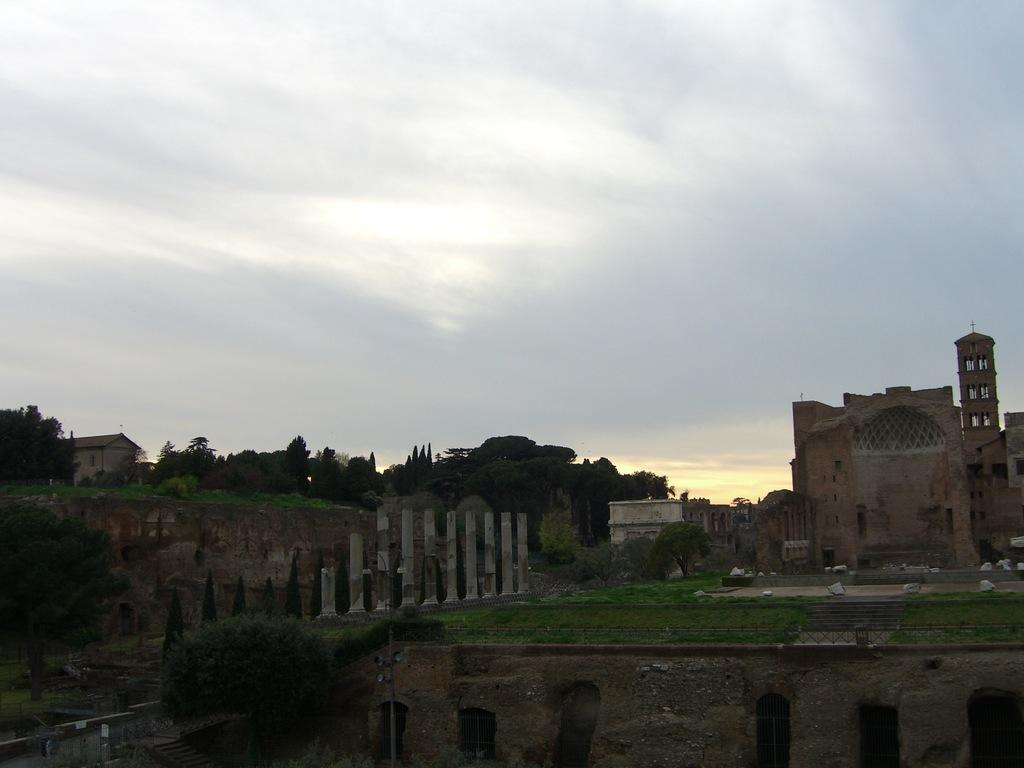What type of natural elements can be seen in the image? There are trees in the image. What man-made structures are present in the image? There are monuments and buildings in the image. How would you describe the sky in the image? The sky is cloudy in the image. Can you see the river flowing through the image? There is no river present in the image. What type of string is being used to hold the buildings together in the image? There is no string visible in the image, and the buildings are not being held together by any visible means. 